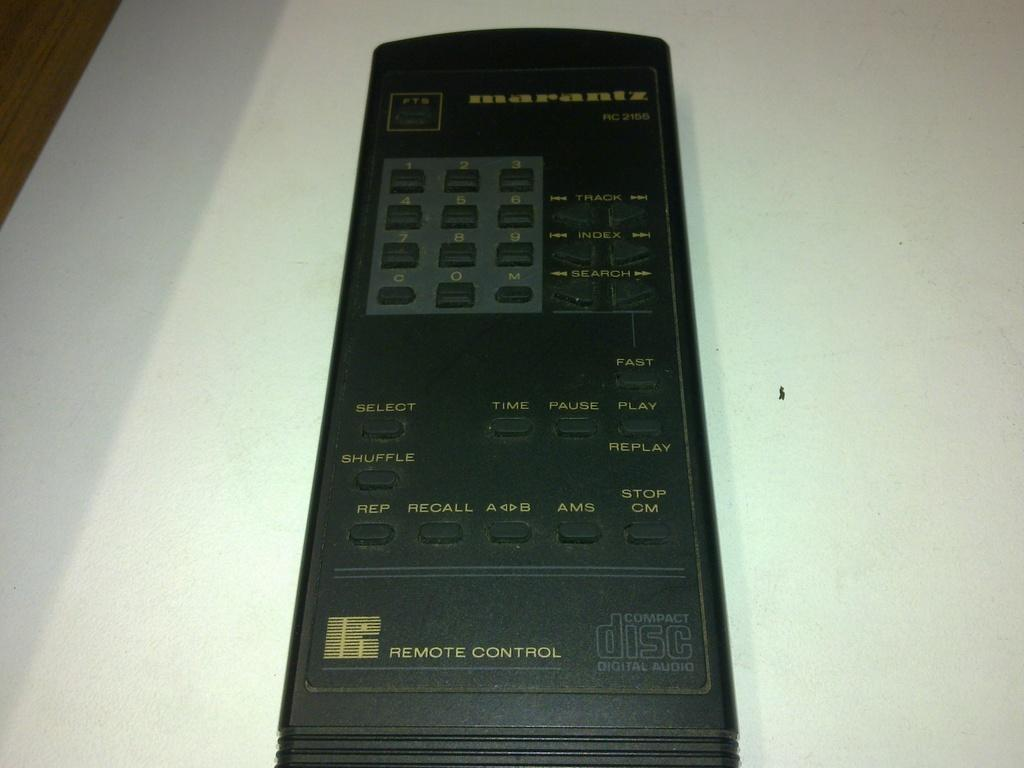What object can be seen in the image? There is a remote in the image. What is the color of the surface on which the remote is placed? The remote is on a white color surface. What type of attraction can be seen in the image? There is no attraction present in the image; it only features a remote on a white surface. 